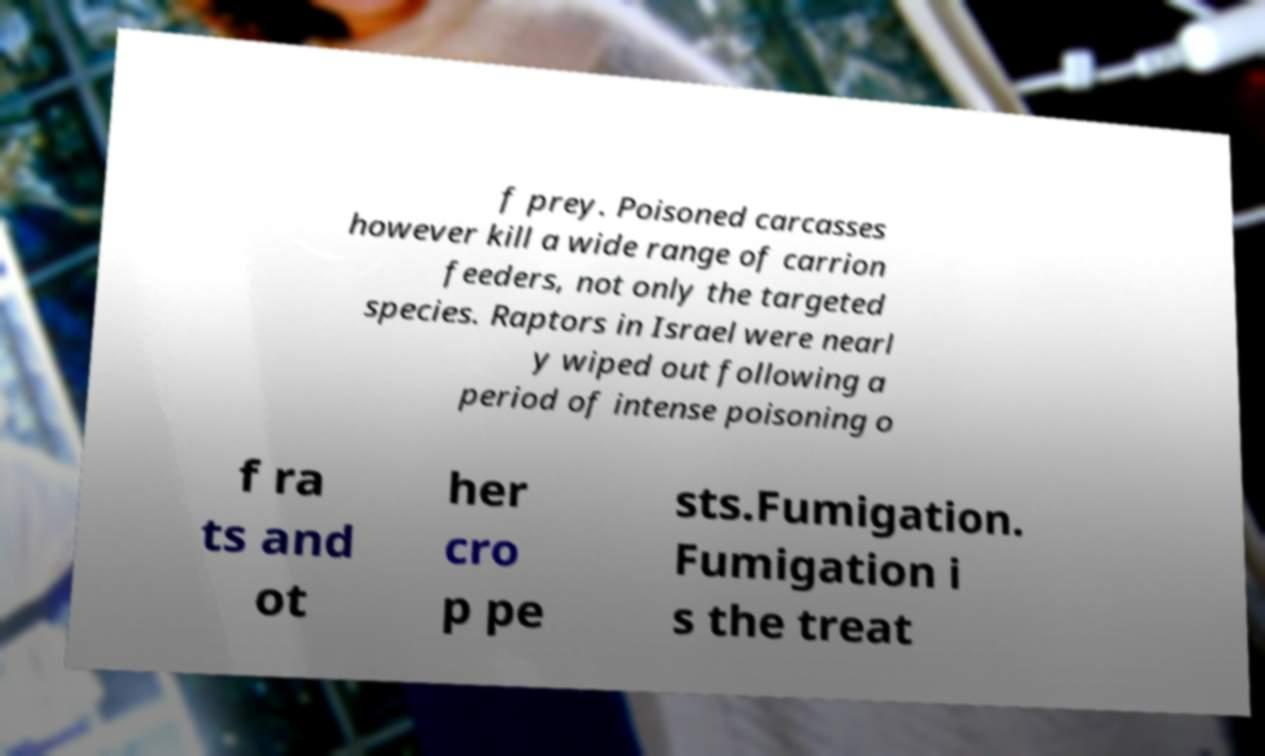I need the written content from this picture converted into text. Can you do that? f prey. Poisoned carcasses however kill a wide range of carrion feeders, not only the targeted species. Raptors in Israel were nearl y wiped out following a period of intense poisoning o f ra ts and ot her cro p pe sts.Fumigation. Fumigation i s the treat 